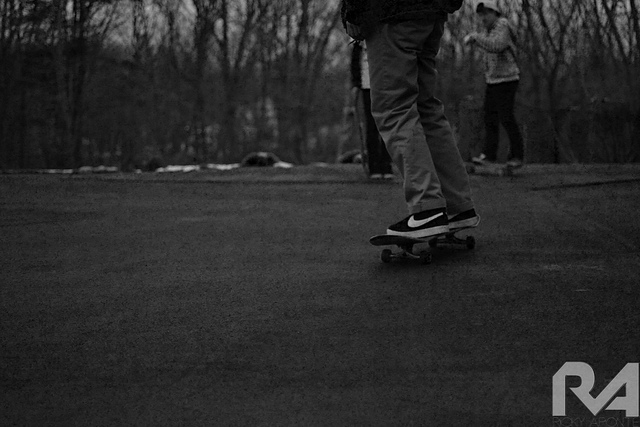Identify the text contained in this image. R4 